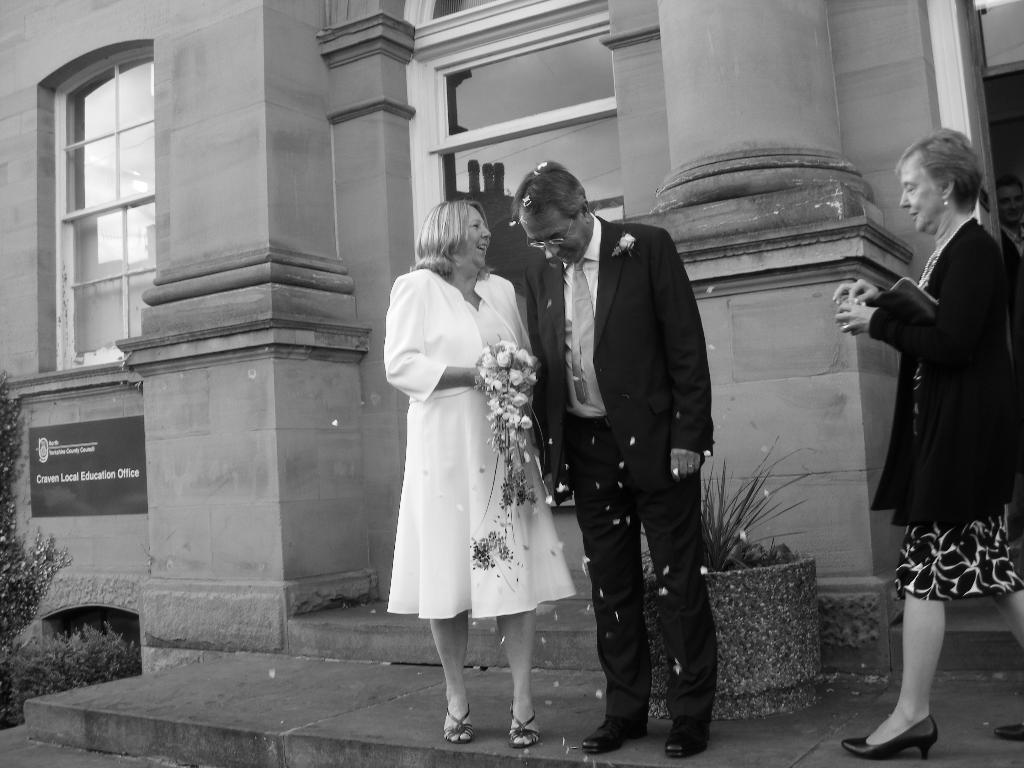How many people are present in the image? There are three people in the image. What is the woman holding in the image? One woman is holding flowers. What can be seen in the background of the image? There is a building in the background of the image. What type of cork can be seen on the ground in the image? There is no cork present on the ground in the image. How many people are resting in the image? The image does not show any people resting; it shows three people standing or holding objects. 